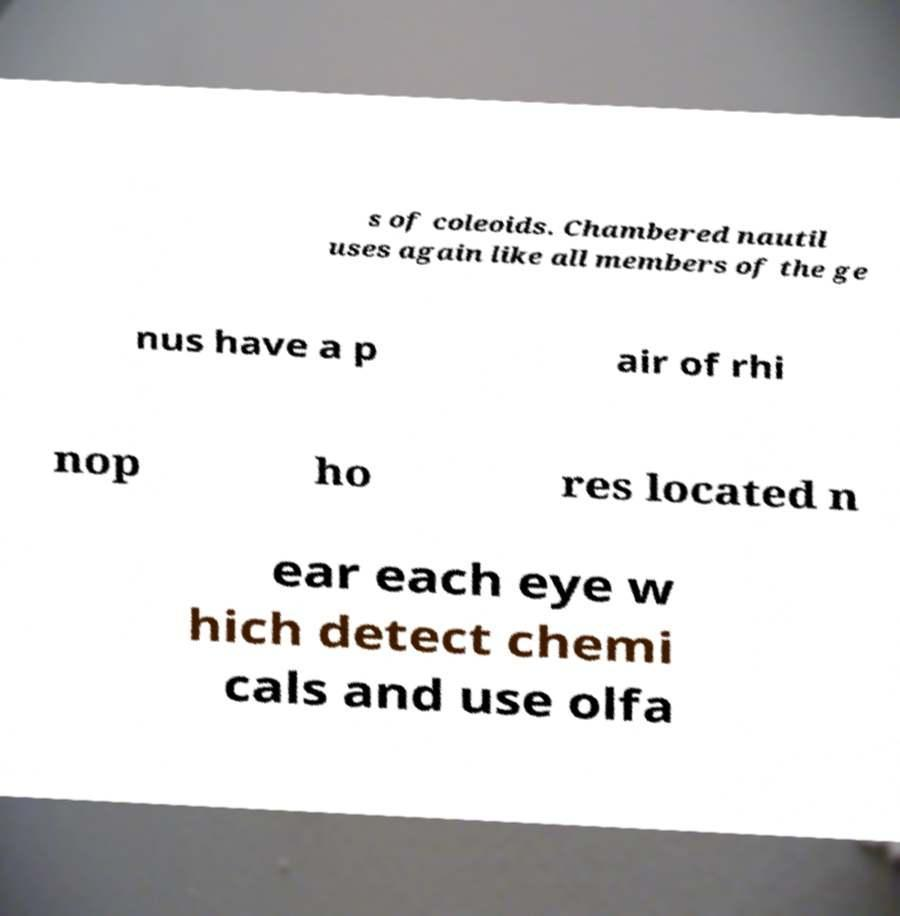Could you assist in decoding the text presented in this image and type it out clearly? s of coleoids. Chambered nautil uses again like all members of the ge nus have a p air of rhi nop ho res located n ear each eye w hich detect chemi cals and use olfa 